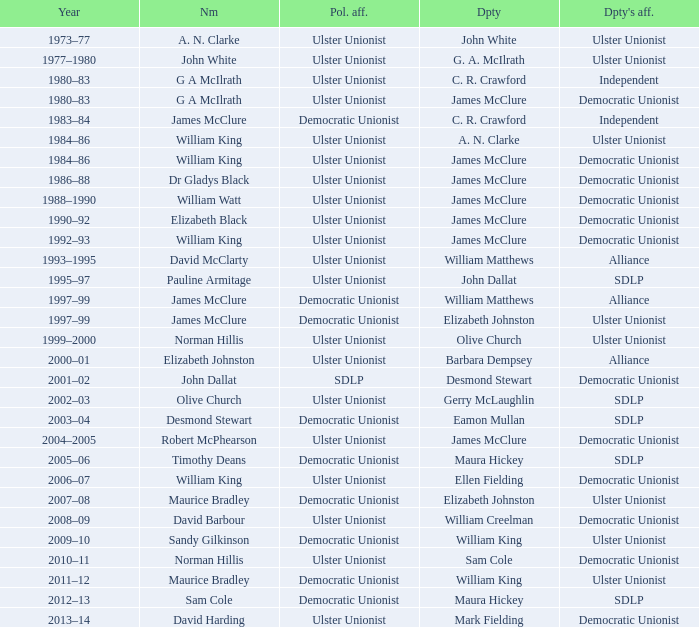What is the Deputy's affiliation in 1992–93? Democratic Unionist. 